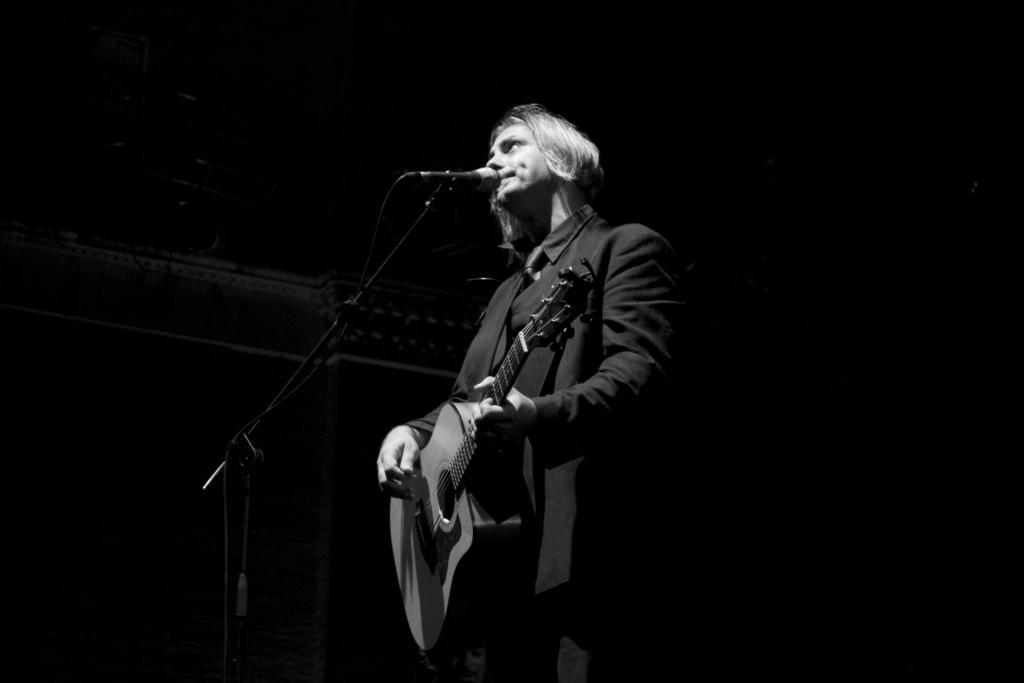Can you describe this image briefly? There is a man in the image standing and playing guitar. He is singing a song using a mike. There is a mike stand at which the mike is fixed to the stand. The background is dark. This man wore suit and tie. 